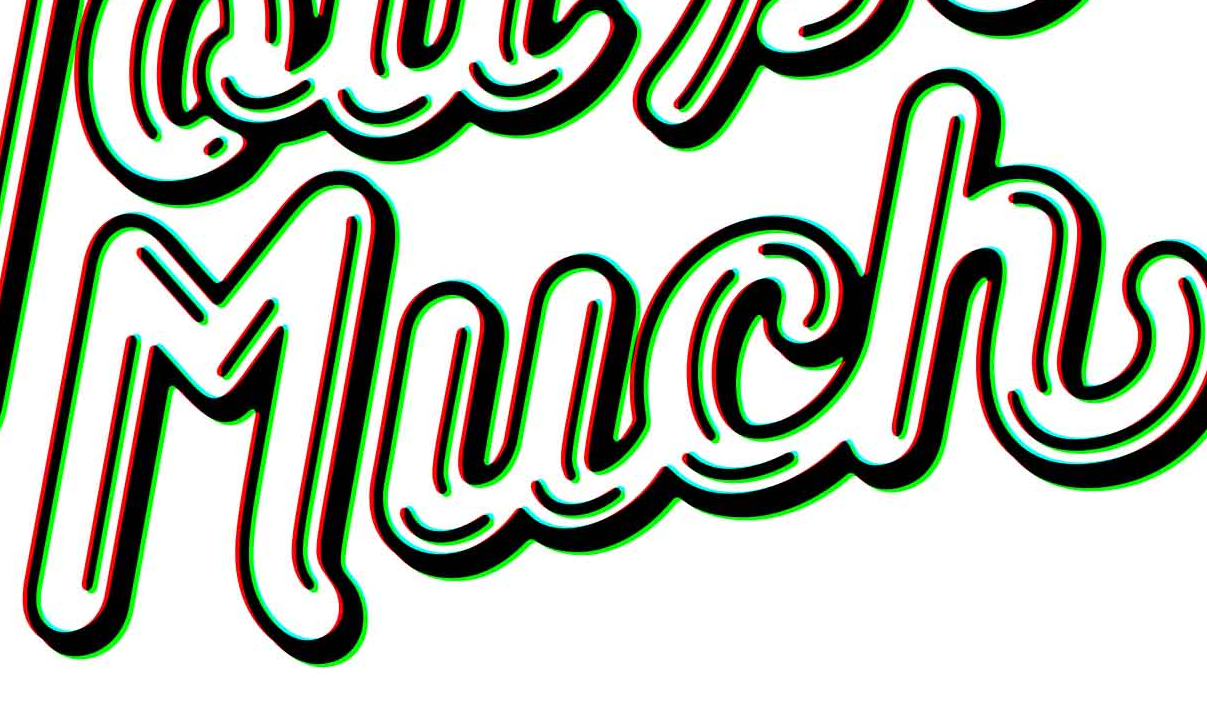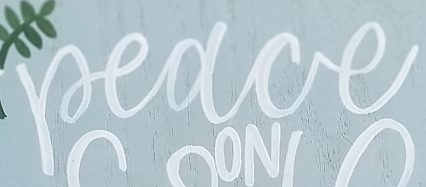What text appears in these images from left to right, separated by a semicolon? Much; Peace 